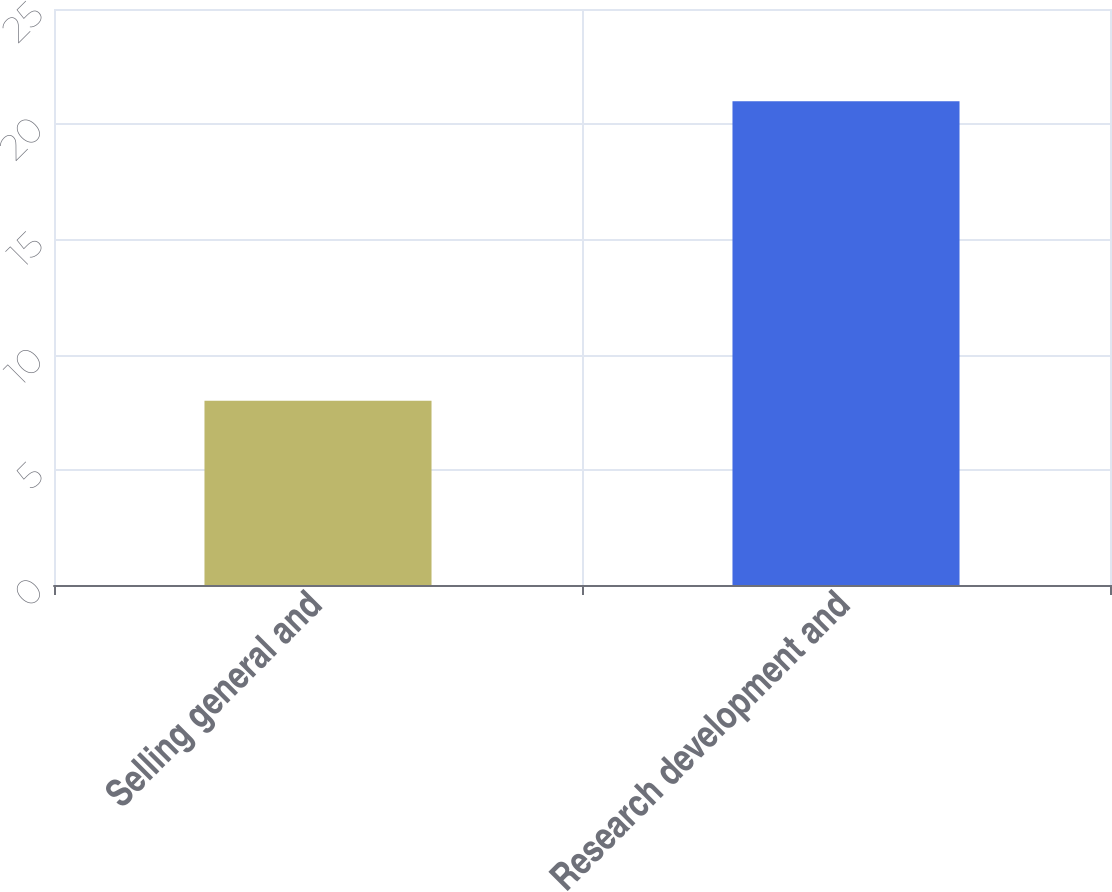Convert chart to OTSL. <chart><loc_0><loc_0><loc_500><loc_500><bar_chart><fcel>Selling general and<fcel>Research development and<nl><fcel>8<fcel>21<nl></chart> 